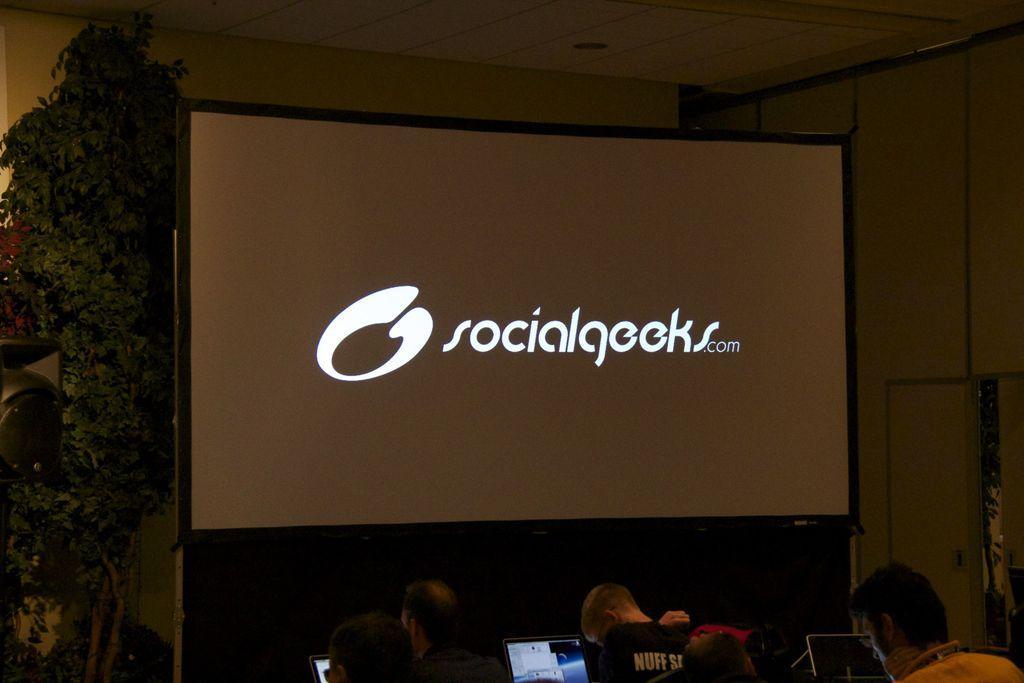Could you give a brief overview of what you see in this image? In this picture we can see a few people, laptops, trees and other objects. We can see the text and a few things on the screen. 